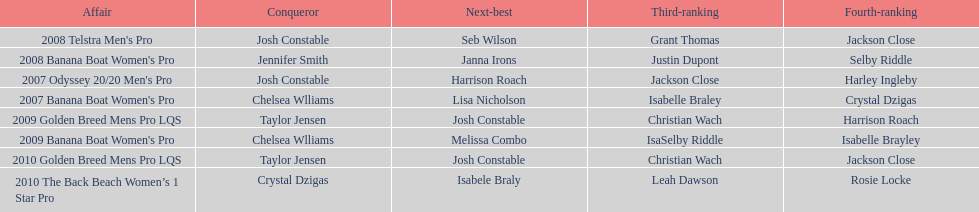In what event did chelsea williams win her first title? 2007 Banana Boat Women's Pro. 